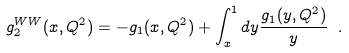Convert formula to latex. <formula><loc_0><loc_0><loc_500><loc_500>g _ { 2 } ^ { W W } ( x , Q ^ { 2 } ) = - g _ { 1 } ( x , Q ^ { 2 } ) + \int _ { x } ^ { 1 } d y \frac { g _ { 1 } ( y , Q ^ { 2 } ) } { y } \ .</formula> 